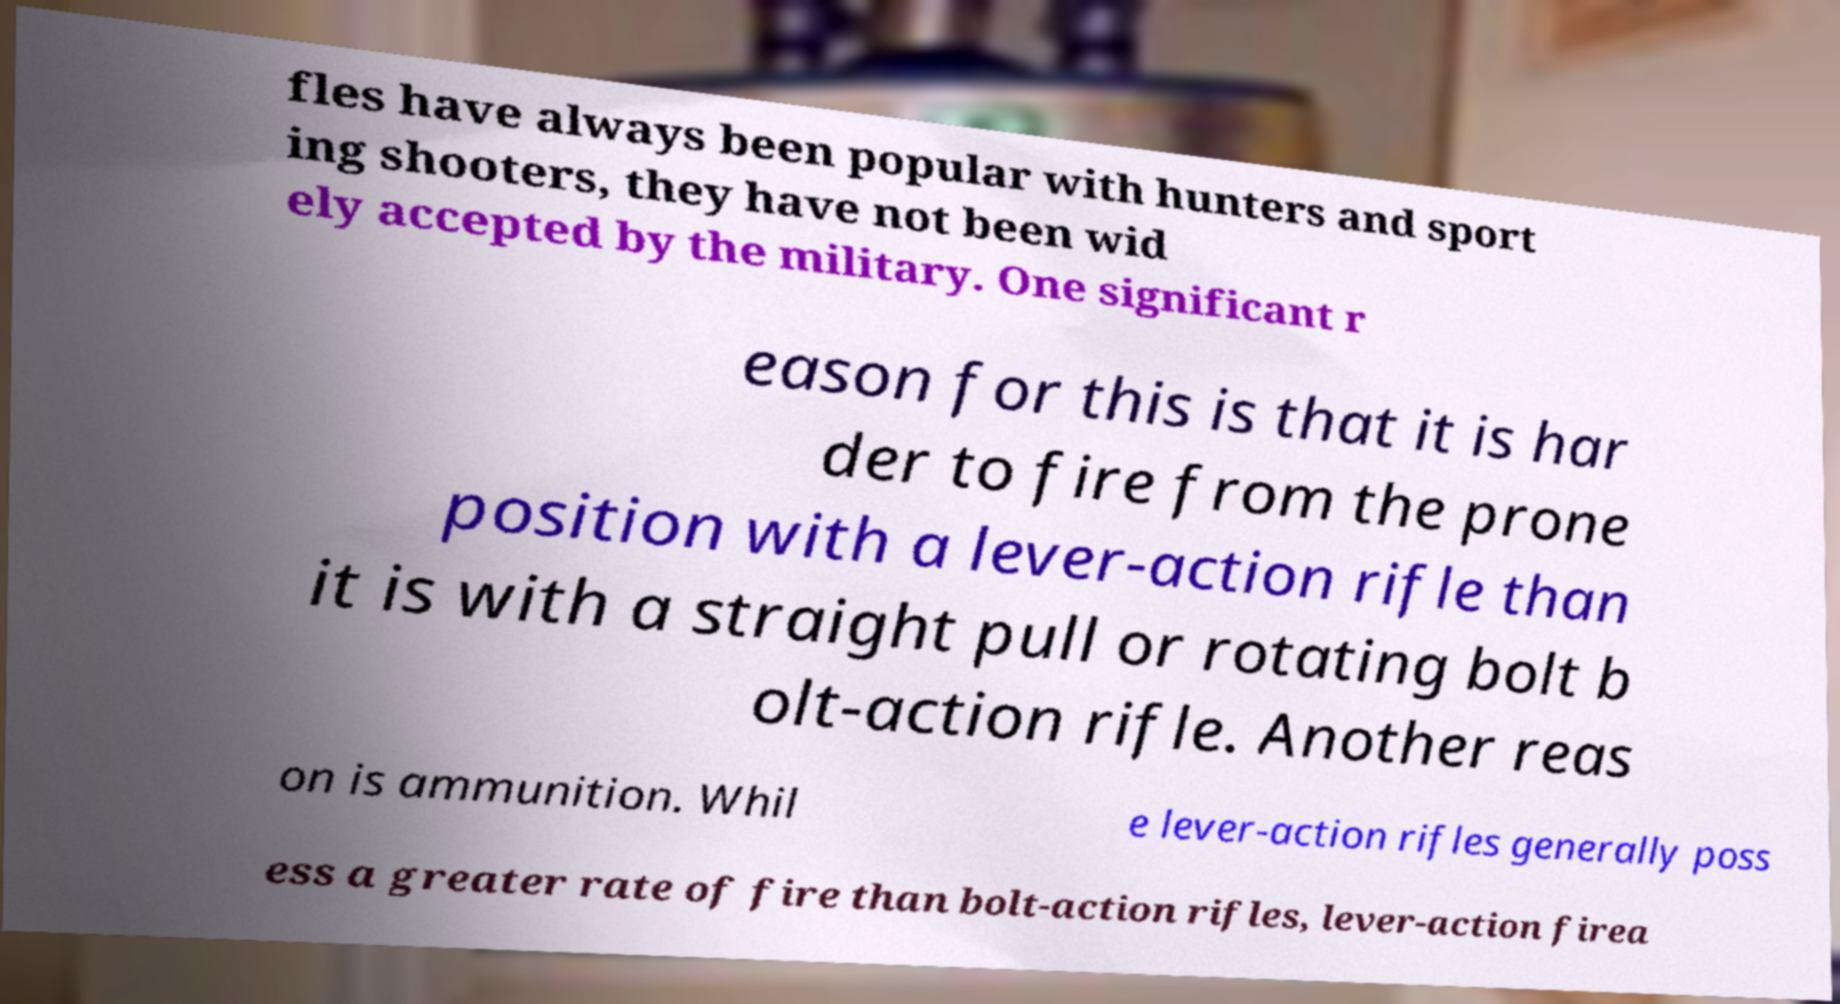Could you assist in decoding the text presented in this image and type it out clearly? fles have always been popular with hunters and sport ing shooters, they have not been wid ely accepted by the military. One significant r eason for this is that it is har der to fire from the prone position with a lever-action rifle than it is with a straight pull or rotating bolt b olt-action rifle. Another reas on is ammunition. Whil e lever-action rifles generally poss ess a greater rate of fire than bolt-action rifles, lever-action firea 